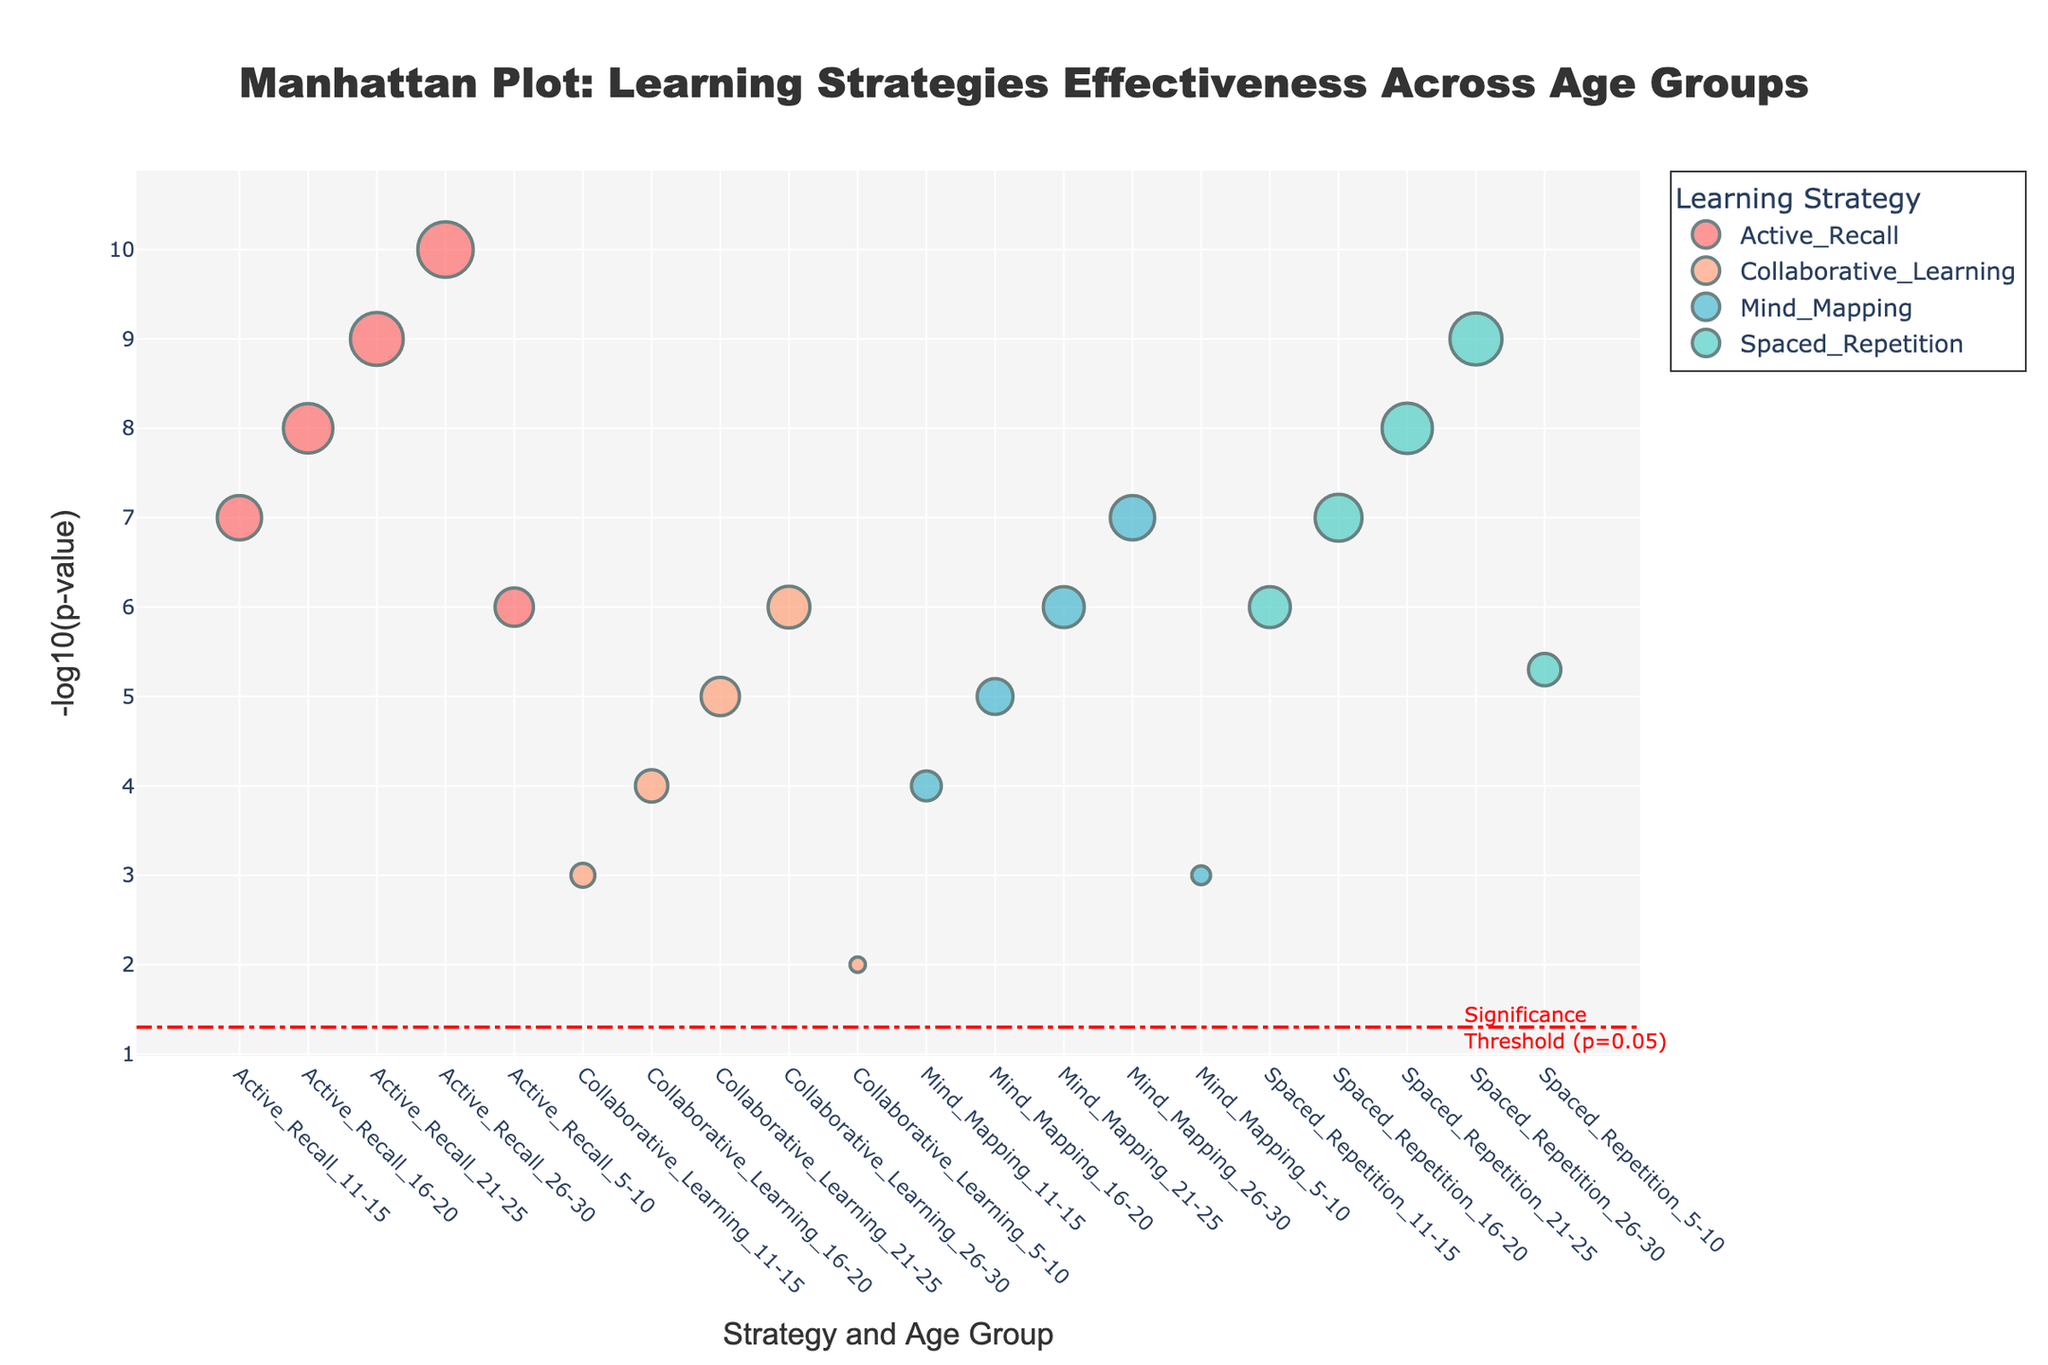What's the title of the plot? The title of the plot is given at the top of the figure. It is "Manhattan Plot: Learning Strategies Effectiveness Across Age Groups"
Answer: Manhattan Plot: Learning Strategies Effectiveness Across Age Groups Which strategy for the age group 21-25 has the highest -log10(p-value)? Look at the data points labeled with the age group 21-25. Compare their -log10(p-values). The highest point corresponds to the lowest p-value.
Answer: Active Recall How many strategies have a significant effect size threshold greater than the significance threshold? Significant strategies are those with a -log10(p-value) above the red threshold line for p=0.05. Count the relevant points across the strategies.
Answer: 16 Comparing Active Recall and Spaced Repetition for the age group 26-30, which strategy has a higher effect size? Find the points for Active Recall and Spaced Repetition in the age group 26-30 and compare their effect sizes (indicated by the size of the markers).
Answer: Active Recall What does the significance threshold line represent in the plot? The horizontal dashed red line indicates the p-value threshold of 0.05 for statistical significance. Data points above this line have p-values lower than 0.05, indicating significant results.
Answer: p-value threshold of 0.05 What is the overall trend observed in the effectiveness of Active Recall across age groups? Observe the -log10(p-value) and marker sizes for Active Recall across the age groups to identify the trend. The markers grow larger and their -log10(p-values) increase.
Answer: Increasing effectiveness Among the four strategies, which one shows the least variation in effectiveness across age groups? Look at the consistency of the -log10(p-value) and marker sizes for each strategy across different age groups.
Answer: Collaborative Learning For the age group 5-10, which strategy has the largest effect size, and what is its corresponding p-value? Identify the largest marker for the age group 5-10, then read its corresponding p-value from the plot.
Answer: Active Recall, p-value 0.000001 How does the effectiveness of Mind Mapping change from age group 5-10 to 26-30? Compare the -log10(p-value) and sizes of the markers for Mind Mapping between the age groups 5-10 and 26-30.
Answer: Both -log10(p-value) and effect size increase 